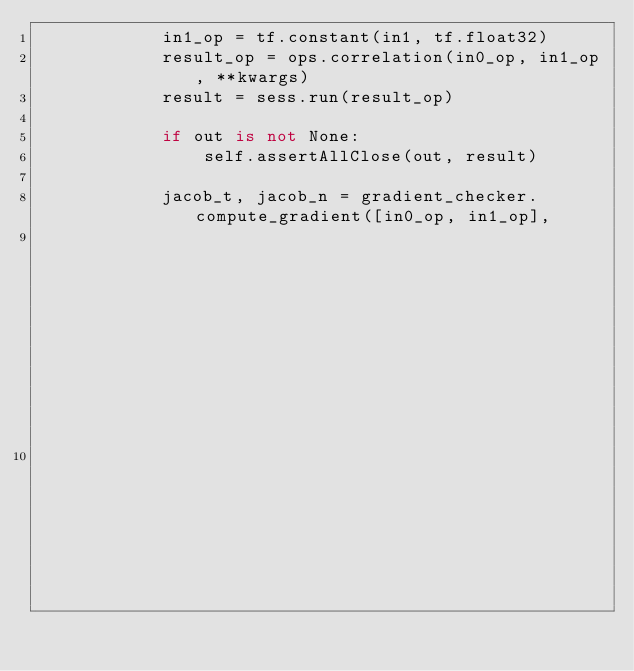Convert code to text. <code><loc_0><loc_0><loc_500><loc_500><_Python_>            in1_op = tf.constant(in1, tf.float32)
            result_op = ops.correlation(in0_op, in1_op, **kwargs)
            result = sess.run(result_op)

            if out is not None:
                self.assertAllClose(out, result)

            jacob_t, jacob_n = gradient_checker.compute_gradient([in0_op, in1_op],
                                                                 [in0.shape, in1.shape],
                                                                 result_op, result.shape)</code> 